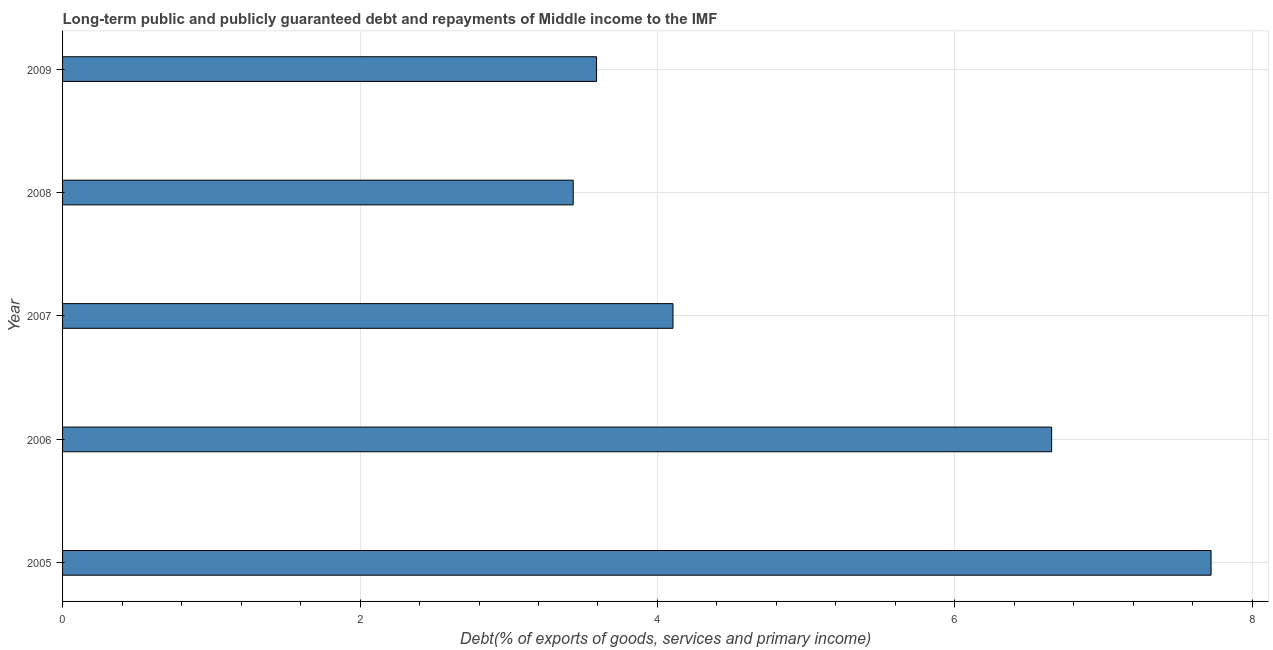Does the graph contain grids?
Your answer should be compact. Yes. What is the title of the graph?
Your response must be concise. Long-term public and publicly guaranteed debt and repayments of Middle income to the IMF. What is the label or title of the X-axis?
Keep it short and to the point. Debt(% of exports of goods, services and primary income). What is the debt service in 2007?
Provide a succinct answer. 4.1. Across all years, what is the maximum debt service?
Ensure brevity in your answer.  7.72. Across all years, what is the minimum debt service?
Your response must be concise. 3.43. What is the sum of the debt service?
Ensure brevity in your answer.  25.5. What is the difference between the debt service in 2007 and 2009?
Your response must be concise. 0.51. What is the average debt service per year?
Ensure brevity in your answer.  5.1. What is the median debt service?
Offer a very short reply. 4.1. What is the ratio of the debt service in 2005 to that in 2006?
Offer a very short reply. 1.16. Is the difference between the debt service in 2005 and 2008 greater than the difference between any two years?
Your response must be concise. Yes. What is the difference between the highest and the second highest debt service?
Your answer should be compact. 1.07. What is the difference between the highest and the lowest debt service?
Give a very brief answer. 4.29. Are all the bars in the graph horizontal?
Ensure brevity in your answer.  Yes. How many years are there in the graph?
Provide a succinct answer. 5. What is the Debt(% of exports of goods, services and primary income) of 2005?
Provide a succinct answer. 7.72. What is the Debt(% of exports of goods, services and primary income) in 2006?
Your answer should be compact. 6.65. What is the Debt(% of exports of goods, services and primary income) of 2007?
Give a very brief answer. 4.1. What is the Debt(% of exports of goods, services and primary income) of 2008?
Provide a succinct answer. 3.43. What is the Debt(% of exports of goods, services and primary income) in 2009?
Ensure brevity in your answer.  3.59. What is the difference between the Debt(% of exports of goods, services and primary income) in 2005 and 2006?
Make the answer very short. 1.07. What is the difference between the Debt(% of exports of goods, services and primary income) in 2005 and 2007?
Keep it short and to the point. 3.62. What is the difference between the Debt(% of exports of goods, services and primary income) in 2005 and 2008?
Give a very brief answer. 4.29. What is the difference between the Debt(% of exports of goods, services and primary income) in 2005 and 2009?
Provide a short and direct response. 4.13. What is the difference between the Debt(% of exports of goods, services and primary income) in 2006 and 2007?
Provide a succinct answer. 2.55. What is the difference between the Debt(% of exports of goods, services and primary income) in 2006 and 2008?
Ensure brevity in your answer.  3.22. What is the difference between the Debt(% of exports of goods, services and primary income) in 2006 and 2009?
Offer a very short reply. 3.06. What is the difference between the Debt(% of exports of goods, services and primary income) in 2007 and 2008?
Your response must be concise. 0.67. What is the difference between the Debt(% of exports of goods, services and primary income) in 2007 and 2009?
Provide a short and direct response. 0.51. What is the difference between the Debt(% of exports of goods, services and primary income) in 2008 and 2009?
Offer a very short reply. -0.16. What is the ratio of the Debt(% of exports of goods, services and primary income) in 2005 to that in 2006?
Offer a very short reply. 1.16. What is the ratio of the Debt(% of exports of goods, services and primary income) in 2005 to that in 2007?
Provide a short and direct response. 1.88. What is the ratio of the Debt(% of exports of goods, services and primary income) in 2005 to that in 2008?
Provide a succinct answer. 2.25. What is the ratio of the Debt(% of exports of goods, services and primary income) in 2005 to that in 2009?
Provide a succinct answer. 2.15. What is the ratio of the Debt(% of exports of goods, services and primary income) in 2006 to that in 2007?
Offer a terse response. 1.62. What is the ratio of the Debt(% of exports of goods, services and primary income) in 2006 to that in 2008?
Offer a very short reply. 1.94. What is the ratio of the Debt(% of exports of goods, services and primary income) in 2006 to that in 2009?
Your answer should be very brief. 1.85. What is the ratio of the Debt(% of exports of goods, services and primary income) in 2007 to that in 2008?
Keep it short and to the point. 1.2. What is the ratio of the Debt(% of exports of goods, services and primary income) in 2007 to that in 2009?
Make the answer very short. 1.14. What is the ratio of the Debt(% of exports of goods, services and primary income) in 2008 to that in 2009?
Keep it short and to the point. 0.96. 